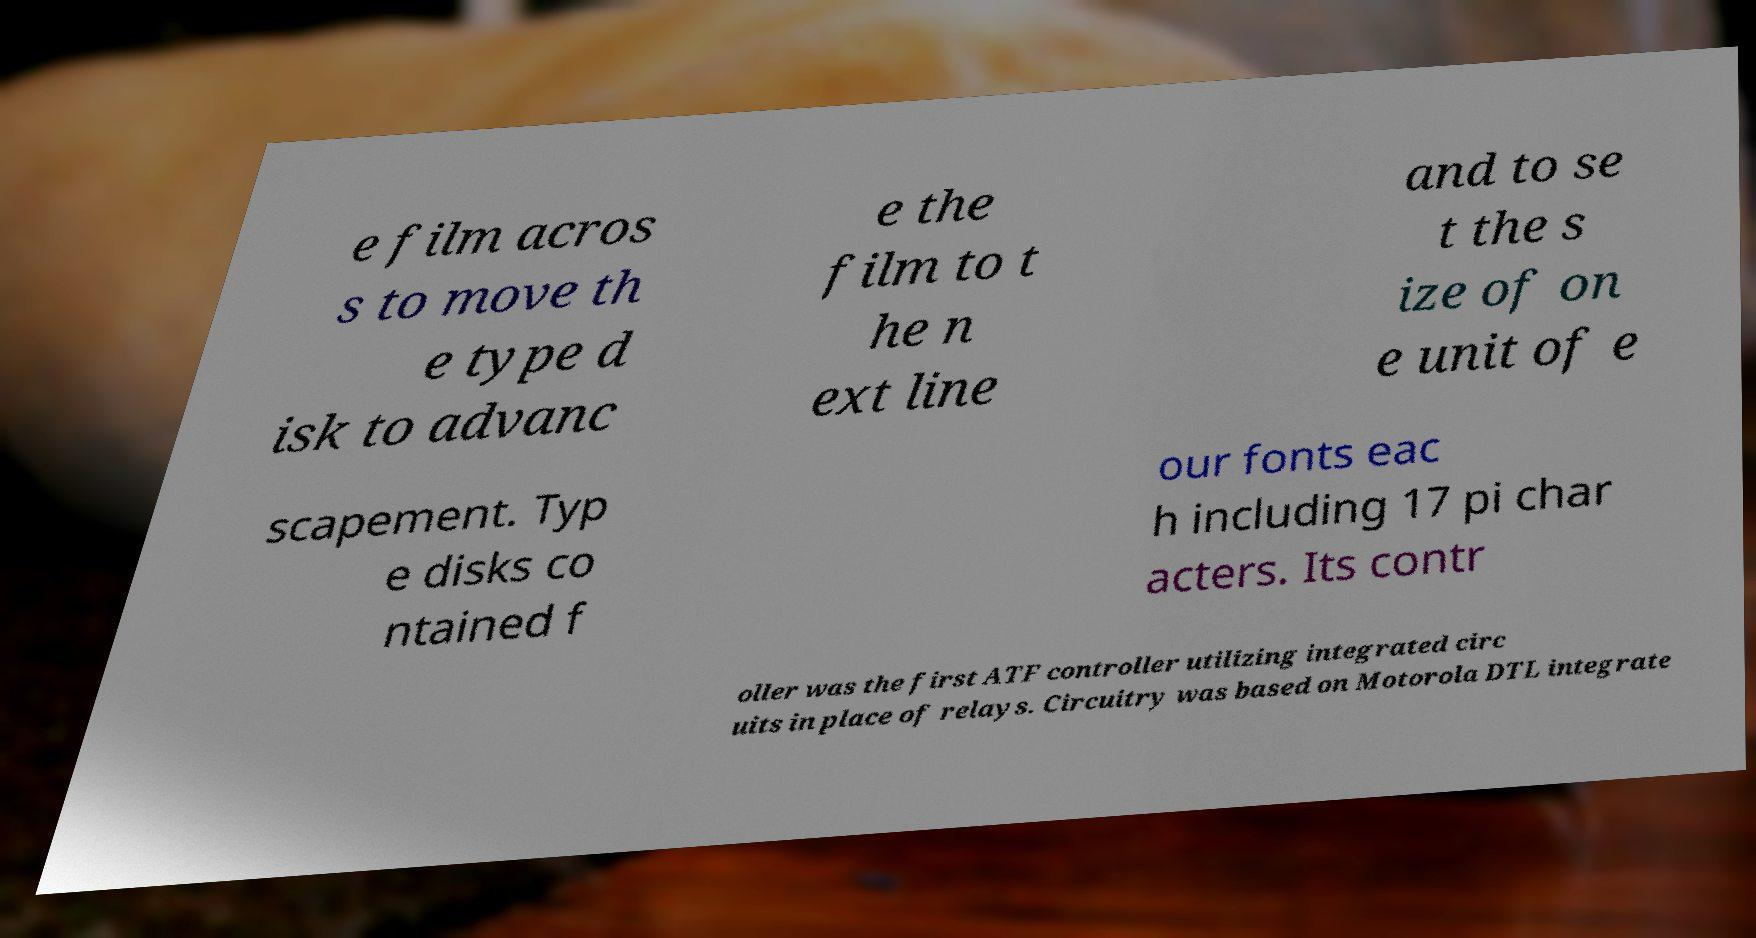Could you assist in decoding the text presented in this image and type it out clearly? e film acros s to move th e type d isk to advanc e the film to t he n ext line and to se t the s ize of on e unit of e scapement. Typ e disks co ntained f our fonts eac h including 17 pi char acters. Its contr oller was the first ATF controller utilizing integrated circ uits in place of relays. Circuitry was based on Motorola DTL integrate 